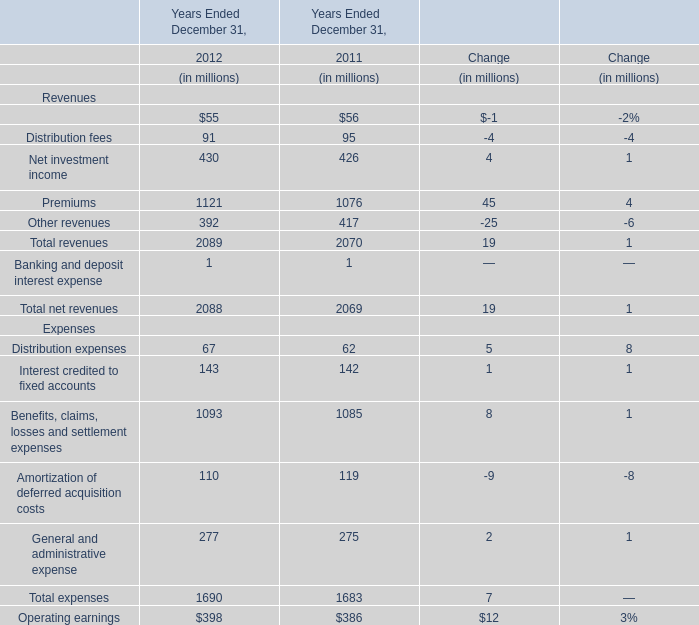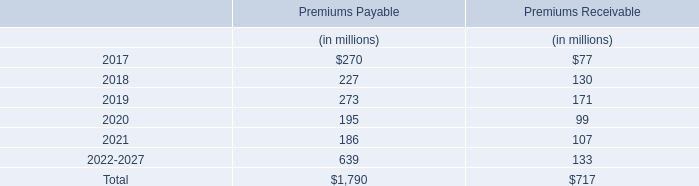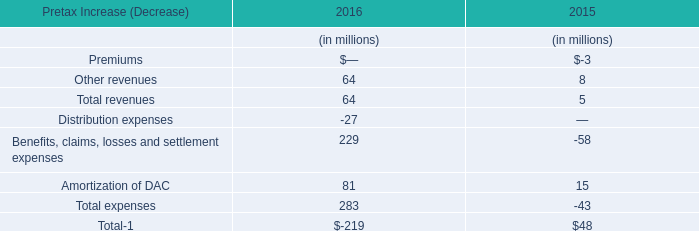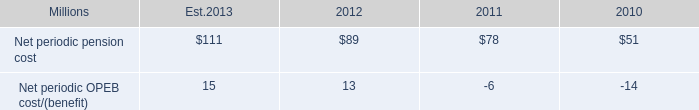What's the growth rate of total net revenues in 2012? 
Computations: ((2088 - 2069) / 2069)
Answer: 0.00918. 